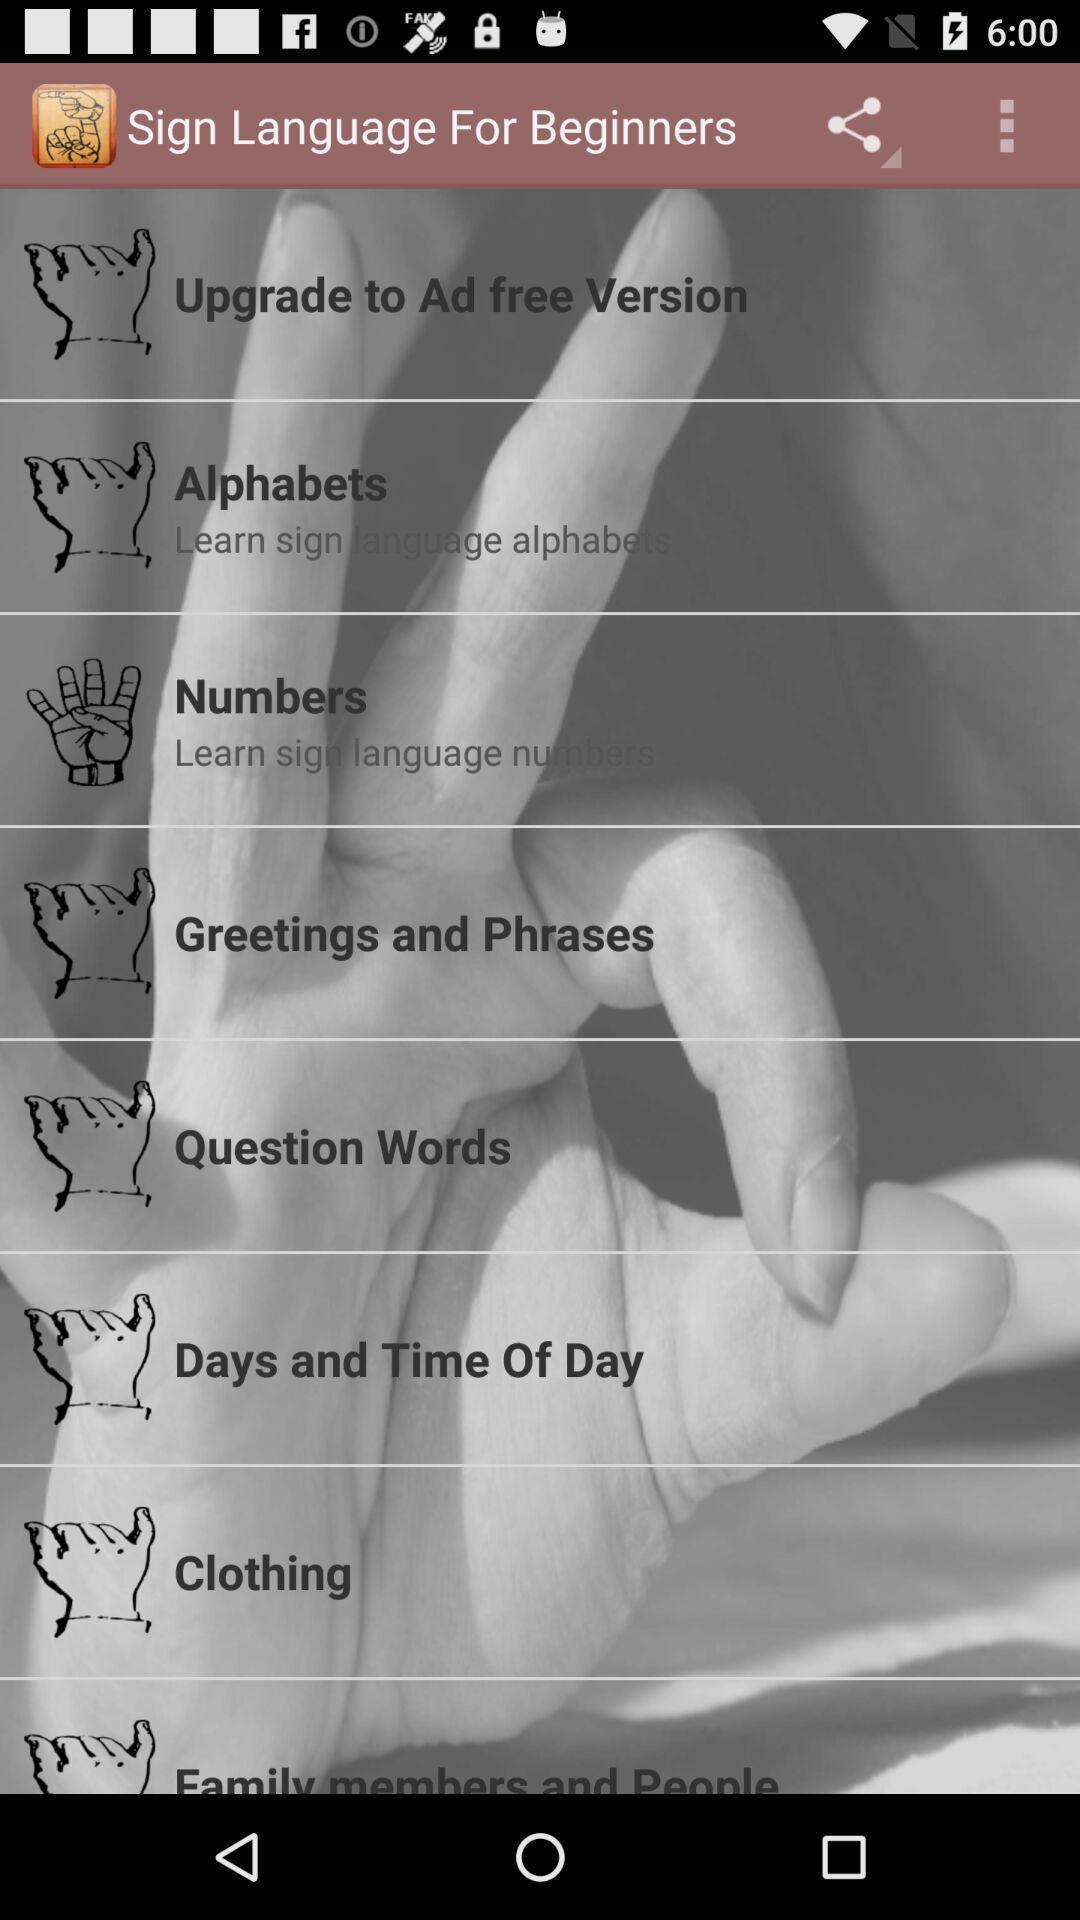Describe the content in this image. Screen displaying multiple hand figures with lesson names. 